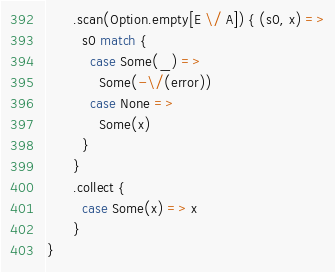Convert code to text. <code><loc_0><loc_0><loc_500><loc_500><_Scala_>      .scan(Option.empty[E \/ A]) { (s0, x) =>
        s0 match {
          case Some(_) =>
            Some(-\/(error))
          case None =>
            Some(x)
        }
      }
      .collect {
        case Some(x) => x
      }
}
</code> 